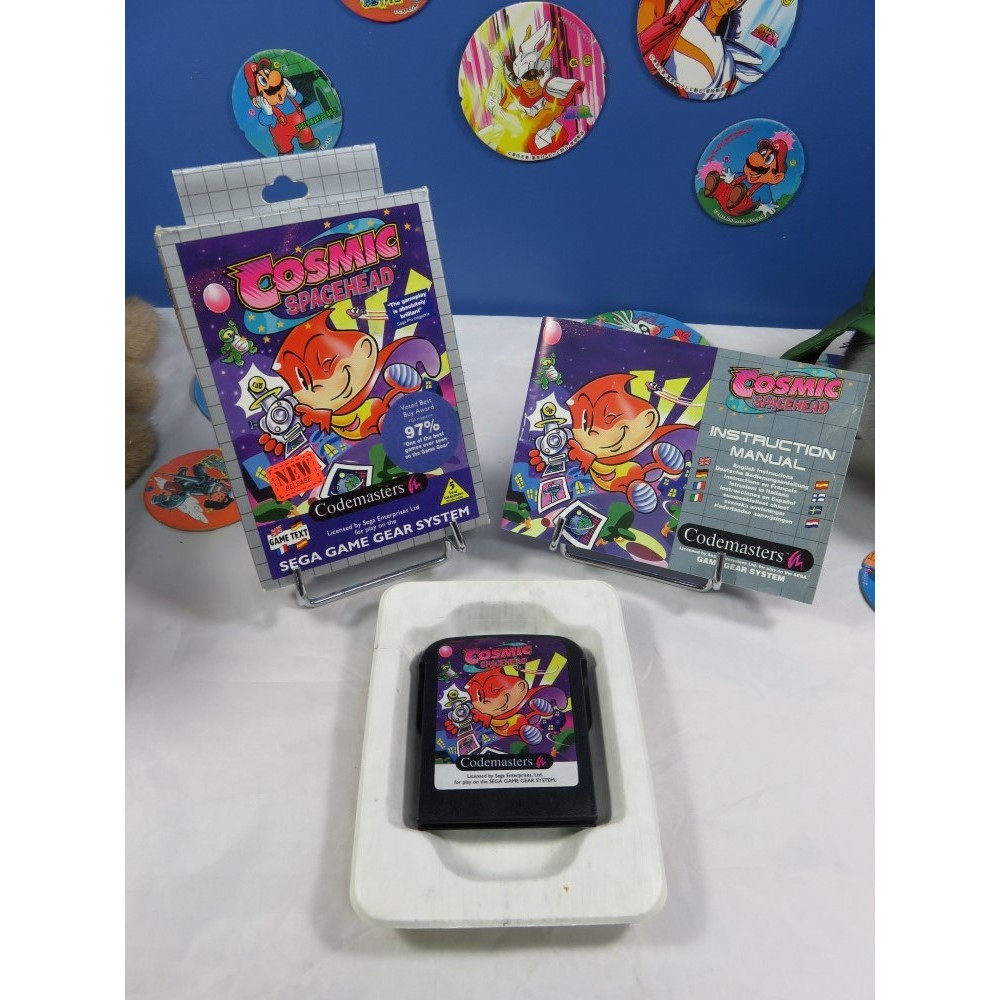If 'Cosmic Spacehead' were adapted into an animated series, what would be a fitting plot for the first episode? If 'Cosmic Spacehead' were adapted into an animated series, a fitting plot for the first episode could involve the main character, Cosmic Spacehead, embarking on a quest to recover a stolen important artifact from his home planet, Linoleum. The episode would start with an introduction to Cosmic Spacehead and his quirky personality, followed by the sudden theft that disrupts the peace in his world. Cosmic, using his wits and universal translator gadget, pursues the thief across various colorful and exotic alien planets. Along the way, he encounters and befriends other quirky characters, learning vital skills and forming alliances that help him in his quest. The episode concludes with a thrilling showdown, where Cosmic uses his ingenuity to outsmart the thief and recover the artifact, setting the stage for more adventures in subsequent episodes. 